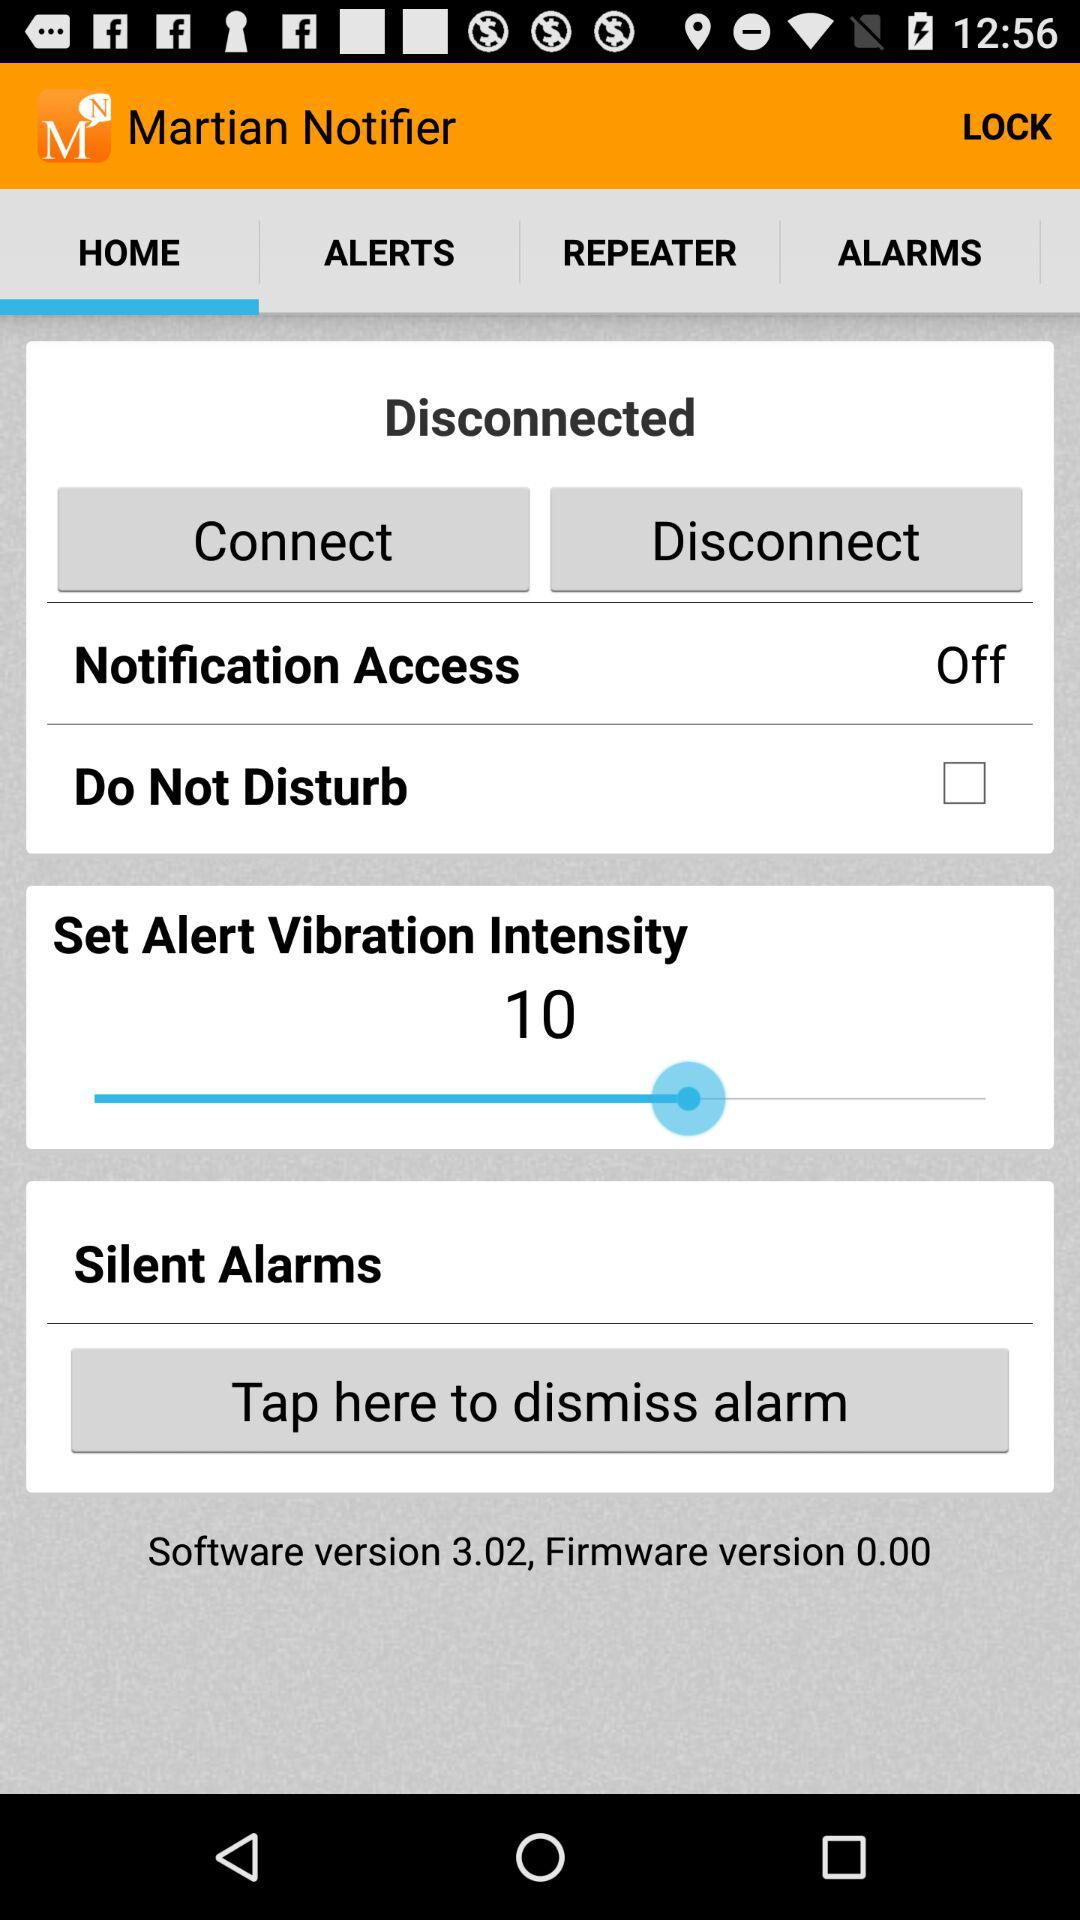Which tab am I on? The tab you are on is "HOME". 